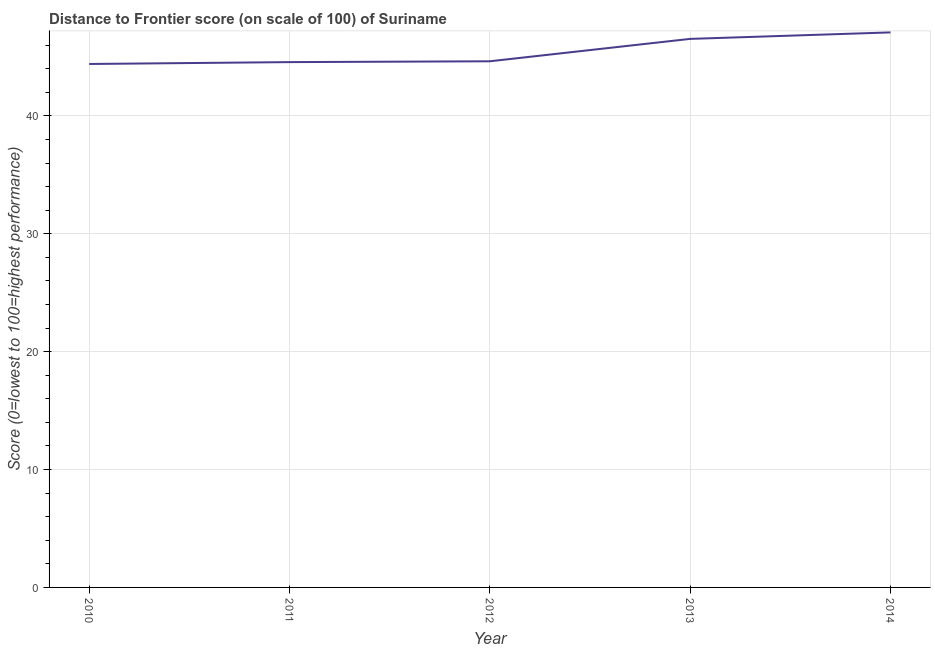What is the distance to frontier score in 2012?
Offer a very short reply. 44.64. Across all years, what is the maximum distance to frontier score?
Provide a short and direct response. 47.09. Across all years, what is the minimum distance to frontier score?
Your answer should be compact. 44.41. In which year was the distance to frontier score maximum?
Make the answer very short. 2014. In which year was the distance to frontier score minimum?
Provide a succinct answer. 2010. What is the sum of the distance to frontier score?
Your answer should be compact. 227.25. What is the difference between the distance to frontier score in 2010 and 2013?
Your answer should be very brief. -2.13. What is the average distance to frontier score per year?
Offer a very short reply. 45.45. What is the median distance to frontier score?
Keep it short and to the point. 44.64. In how many years, is the distance to frontier score greater than 34 ?
Your answer should be very brief. 5. What is the ratio of the distance to frontier score in 2010 to that in 2014?
Your response must be concise. 0.94. What is the difference between the highest and the second highest distance to frontier score?
Your response must be concise. 0.55. Is the sum of the distance to frontier score in 2012 and 2014 greater than the maximum distance to frontier score across all years?
Provide a short and direct response. Yes. What is the difference between the highest and the lowest distance to frontier score?
Offer a terse response. 2.68. In how many years, is the distance to frontier score greater than the average distance to frontier score taken over all years?
Keep it short and to the point. 2. How many years are there in the graph?
Provide a short and direct response. 5. What is the title of the graph?
Give a very brief answer. Distance to Frontier score (on scale of 100) of Suriname. What is the label or title of the X-axis?
Ensure brevity in your answer.  Year. What is the label or title of the Y-axis?
Provide a short and direct response. Score (0=lowest to 100=highest performance). What is the Score (0=lowest to 100=highest performance) of 2010?
Provide a short and direct response. 44.41. What is the Score (0=lowest to 100=highest performance) of 2011?
Keep it short and to the point. 44.57. What is the Score (0=lowest to 100=highest performance) of 2012?
Give a very brief answer. 44.64. What is the Score (0=lowest to 100=highest performance) of 2013?
Keep it short and to the point. 46.54. What is the Score (0=lowest to 100=highest performance) of 2014?
Provide a short and direct response. 47.09. What is the difference between the Score (0=lowest to 100=highest performance) in 2010 and 2011?
Offer a terse response. -0.16. What is the difference between the Score (0=lowest to 100=highest performance) in 2010 and 2012?
Give a very brief answer. -0.23. What is the difference between the Score (0=lowest to 100=highest performance) in 2010 and 2013?
Ensure brevity in your answer.  -2.13. What is the difference between the Score (0=lowest to 100=highest performance) in 2010 and 2014?
Make the answer very short. -2.68. What is the difference between the Score (0=lowest to 100=highest performance) in 2011 and 2012?
Ensure brevity in your answer.  -0.07. What is the difference between the Score (0=lowest to 100=highest performance) in 2011 and 2013?
Your answer should be compact. -1.97. What is the difference between the Score (0=lowest to 100=highest performance) in 2011 and 2014?
Make the answer very short. -2.52. What is the difference between the Score (0=lowest to 100=highest performance) in 2012 and 2013?
Ensure brevity in your answer.  -1.9. What is the difference between the Score (0=lowest to 100=highest performance) in 2012 and 2014?
Provide a succinct answer. -2.45. What is the difference between the Score (0=lowest to 100=highest performance) in 2013 and 2014?
Give a very brief answer. -0.55. What is the ratio of the Score (0=lowest to 100=highest performance) in 2010 to that in 2011?
Make the answer very short. 1. What is the ratio of the Score (0=lowest to 100=highest performance) in 2010 to that in 2012?
Your answer should be compact. 0.99. What is the ratio of the Score (0=lowest to 100=highest performance) in 2010 to that in 2013?
Make the answer very short. 0.95. What is the ratio of the Score (0=lowest to 100=highest performance) in 2010 to that in 2014?
Your answer should be compact. 0.94. What is the ratio of the Score (0=lowest to 100=highest performance) in 2011 to that in 2012?
Keep it short and to the point. 1. What is the ratio of the Score (0=lowest to 100=highest performance) in 2011 to that in 2013?
Your answer should be very brief. 0.96. What is the ratio of the Score (0=lowest to 100=highest performance) in 2011 to that in 2014?
Your response must be concise. 0.95. What is the ratio of the Score (0=lowest to 100=highest performance) in 2012 to that in 2013?
Provide a succinct answer. 0.96. What is the ratio of the Score (0=lowest to 100=highest performance) in 2012 to that in 2014?
Offer a terse response. 0.95. What is the ratio of the Score (0=lowest to 100=highest performance) in 2013 to that in 2014?
Provide a succinct answer. 0.99. 